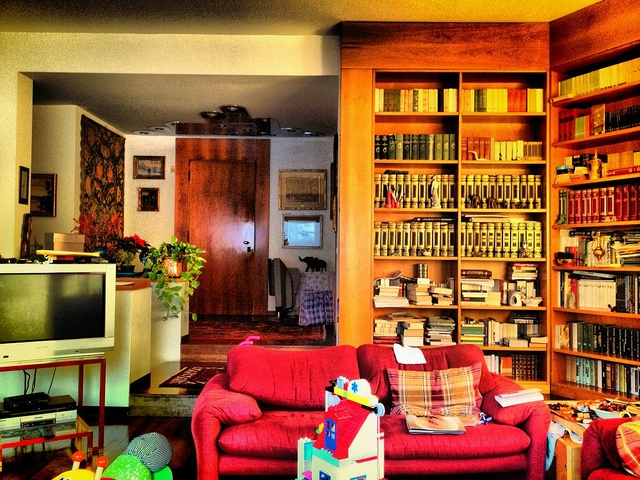Describe the objects in this image and their specific colors. I can see book in black, orange, maroon, and brown tones, couch in black, red, brown, and maroon tones, tv in black, khaki, and olive tones, potted plant in black and olive tones, and dining table in black, gray, purple, and navy tones in this image. 